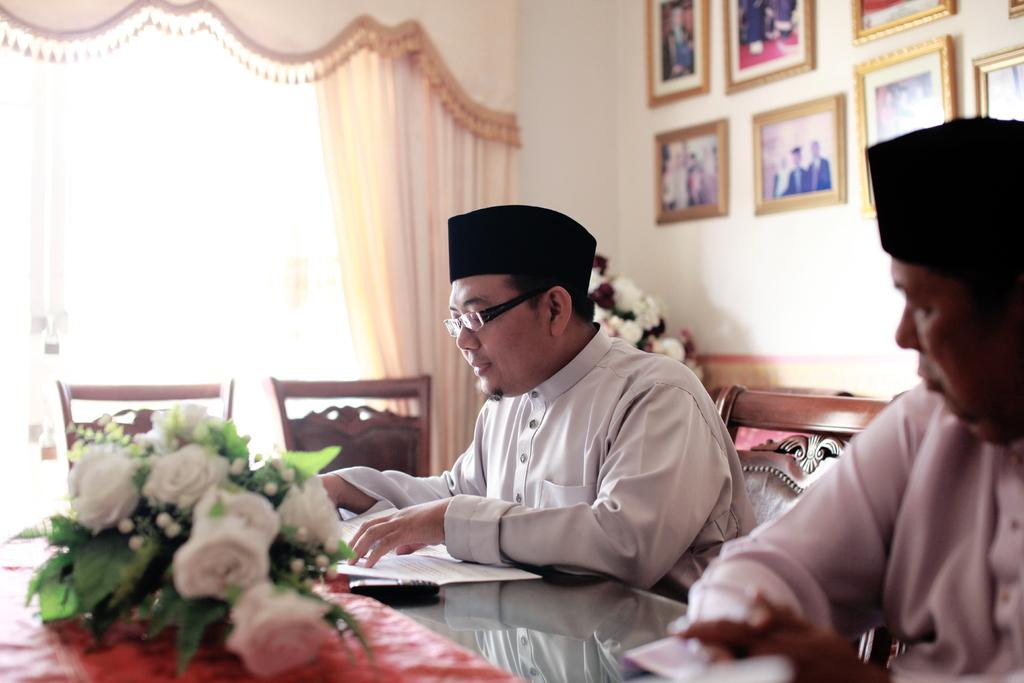How many people are in the image? There are two people in the image. What are the people wearing on their heads? The people are wearing caps. Where are the people sitting in relation to the table? The people are sitting in front of the table. What can be seen on the table besides the people? There is a bouquet and papers on the table. What is present on the wall in the image? There are frames on the wall. What type of bread can be seen on the table in the image? There is no bread present on the table in the image. 